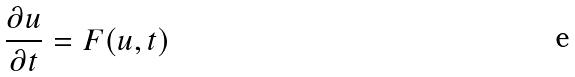Convert formula to latex. <formula><loc_0><loc_0><loc_500><loc_500>\frac { \partial u } { \partial t } = F ( u , t )</formula> 